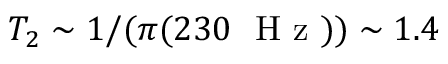Convert formula to latex. <formula><loc_0><loc_0><loc_500><loc_500>T _ { 2 } \sim 1 / ( \pi ( 2 3 0 H z ) ) \sim 1 . 4</formula> 